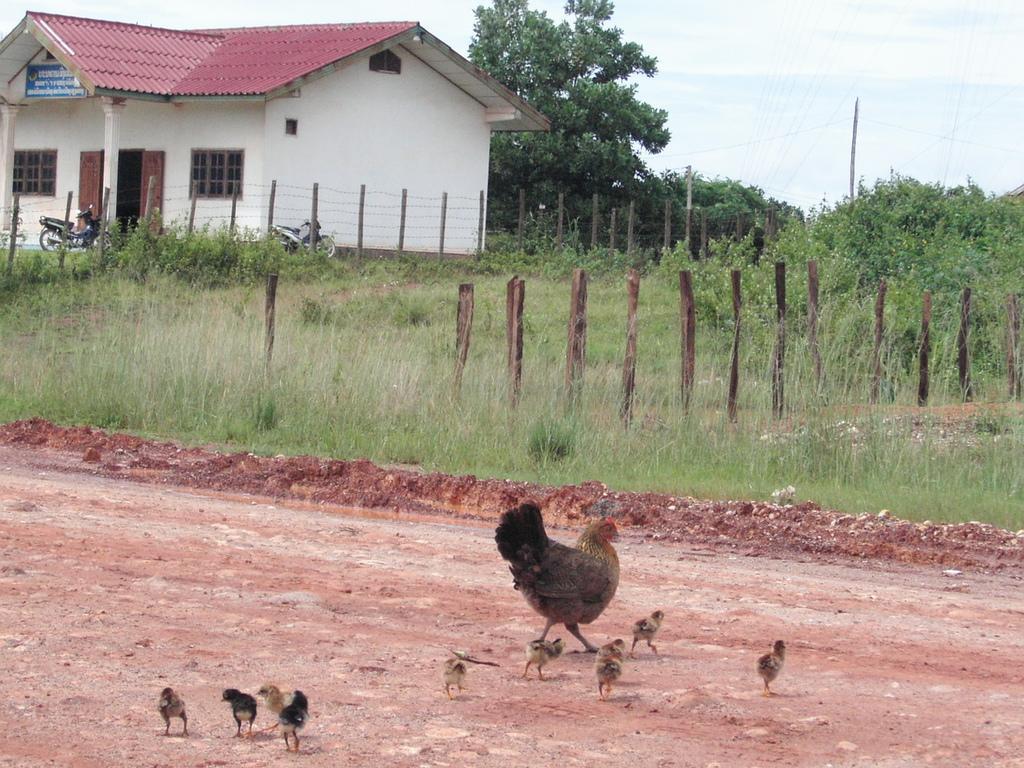Can you describe this image briefly? In this picture we can see a hen and chicks on the ground. Behind the hen, there are wooden poles, wire fencing and grass. At the top of the image, there is a house with doors, windows and a name board. In front of the house, there are vehicles. On the right side of the house, there are trees and the sky. 